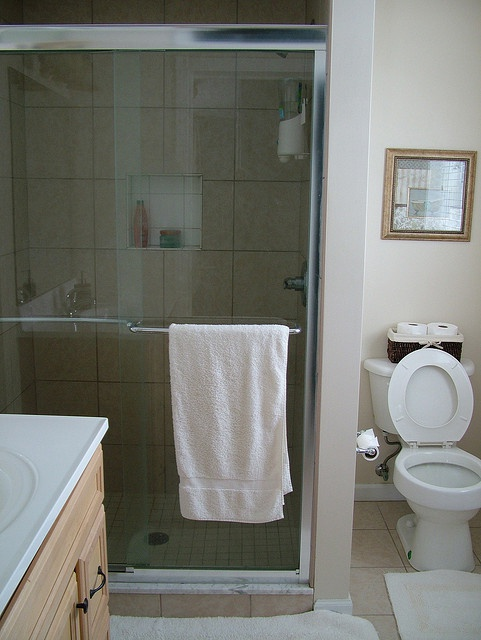Describe the objects in this image and their specific colors. I can see toilet in black, darkgray, gray, and lightgray tones and sink in black, darkgray, lightgray, and lightblue tones in this image. 